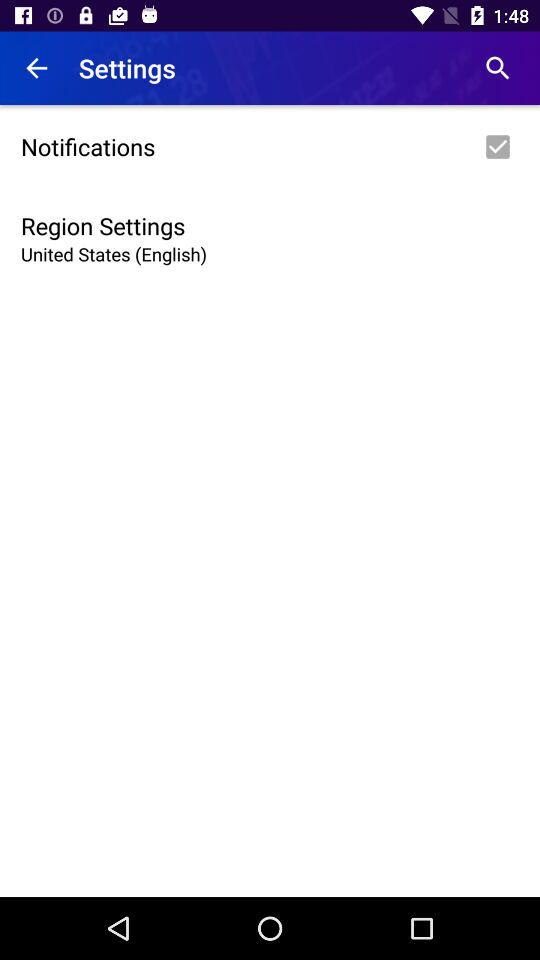What changes can be expected if the region setting is switched from the United States to the United Kingdom? Switching the region setting from the United States to the United Kingdom may alter several aspects of the application, including the language to British English, which affects spelling and phrasing. Additionally, date formats, currency, and other localized content might adjust to align with UK standards. 